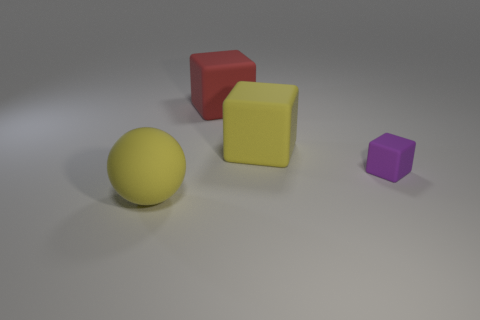Add 2 big blue rubber cylinders. How many objects exist? 6 Subtract all blocks. How many objects are left? 1 Add 1 red rubber objects. How many red rubber objects are left? 2 Add 1 big blocks. How many big blocks exist? 3 Subtract 0 cyan spheres. How many objects are left? 4 Subtract all big yellow matte cubes. Subtract all red objects. How many objects are left? 2 